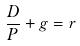<formula> <loc_0><loc_0><loc_500><loc_500>\frac { D } { P } + g = r</formula> 